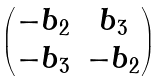<formula> <loc_0><loc_0><loc_500><loc_500>\begin{pmatrix} - b _ { 2 } & b _ { 3 } \\ - b _ { 3 } & - b _ { 2 } \end{pmatrix}</formula> 